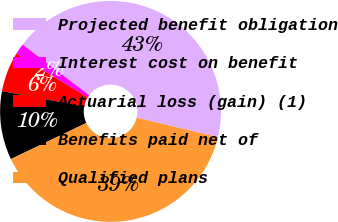Convert chart. <chart><loc_0><loc_0><loc_500><loc_500><pie_chart><fcel>Projected benefit obligation<fcel>Interest cost on benefit<fcel>Actuarial loss (gain) (1)<fcel>Benefits paid net of<fcel>Qualified plans<nl><fcel>43.39%<fcel>1.58%<fcel>5.82%<fcel>10.05%<fcel>39.15%<nl></chart> 